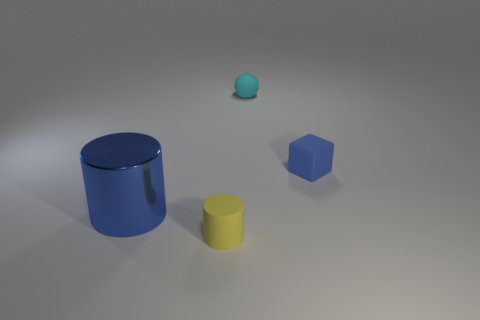Add 2 big brown spheres. How many objects exist? 6 Add 2 big blue objects. How many big blue objects are left? 3 Add 3 big blue metallic things. How many big blue metallic things exist? 4 Subtract 0 red spheres. How many objects are left? 4 Subtract all tiny yellow objects. Subtract all large cylinders. How many objects are left? 2 